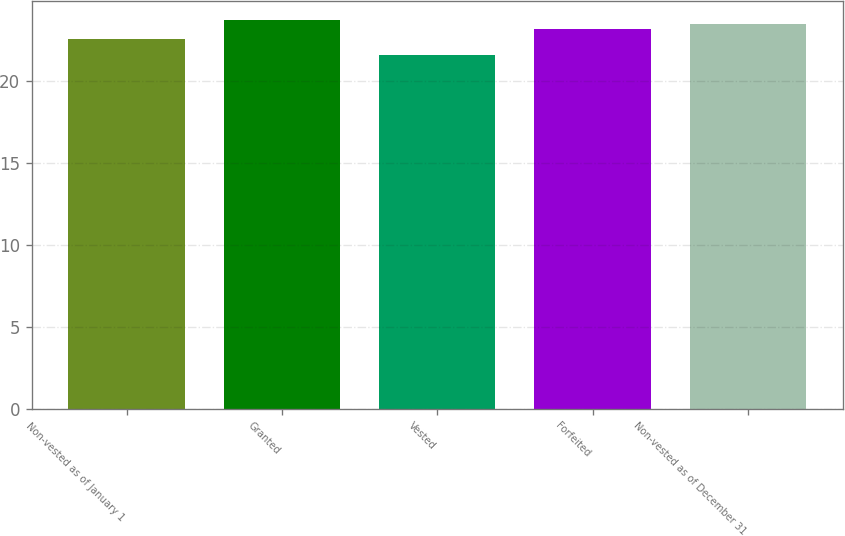Convert chart to OTSL. <chart><loc_0><loc_0><loc_500><loc_500><bar_chart><fcel>Non-vested as of January 1<fcel>Granted<fcel>Vested<fcel>Forfeited<fcel>Non-vested as of December 31<nl><fcel>22.52<fcel>23.68<fcel>21.54<fcel>23.17<fcel>23.47<nl></chart> 